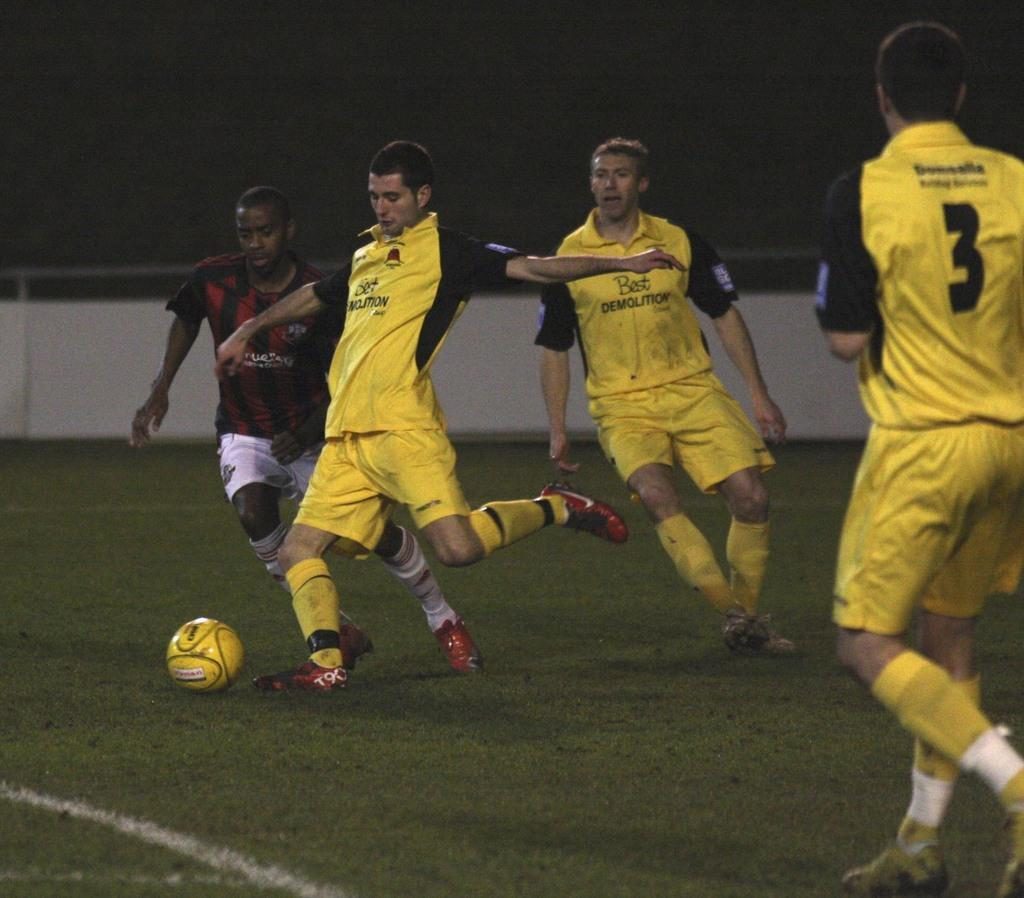<image>
Create a compact narrative representing the image presented. Man wearing a number 3 jersey watching a man about to kick a ball. 